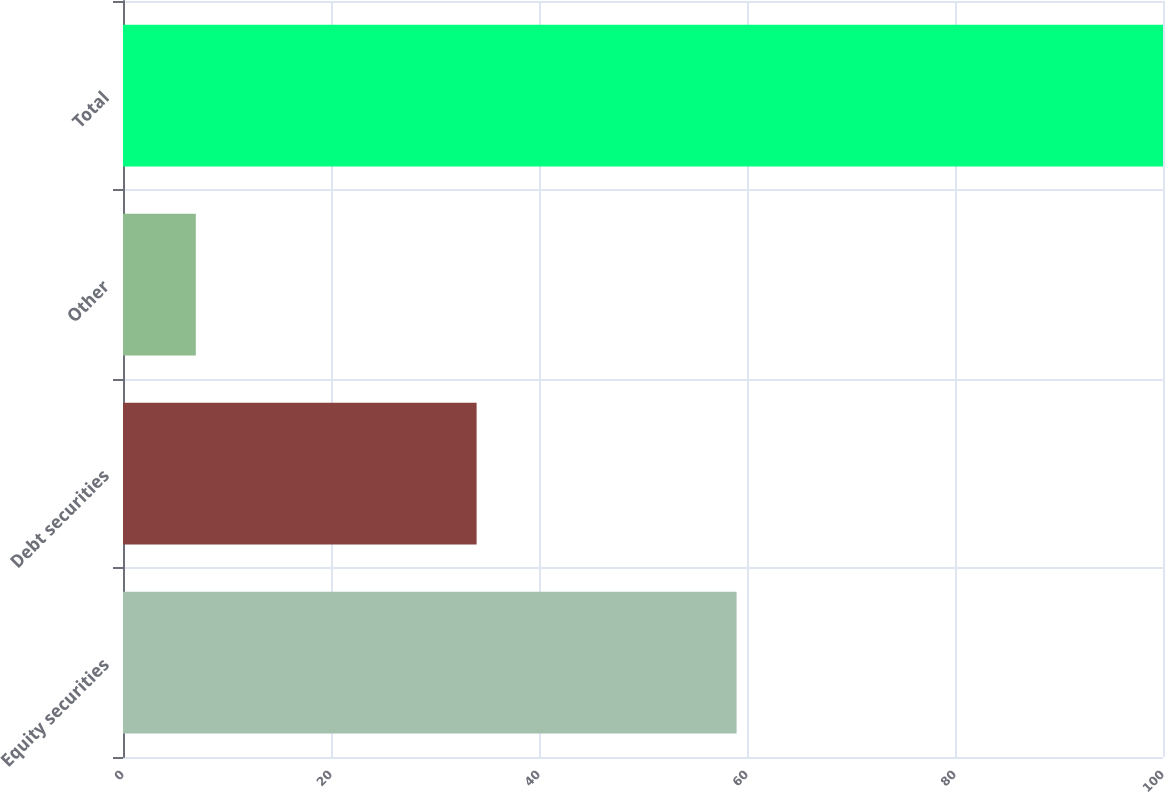Convert chart to OTSL. <chart><loc_0><loc_0><loc_500><loc_500><bar_chart><fcel>Equity securities<fcel>Debt securities<fcel>Other<fcel>Total<nl><fcel>59<fcel>34<fcel>7<fcel>100<nl></chart> 